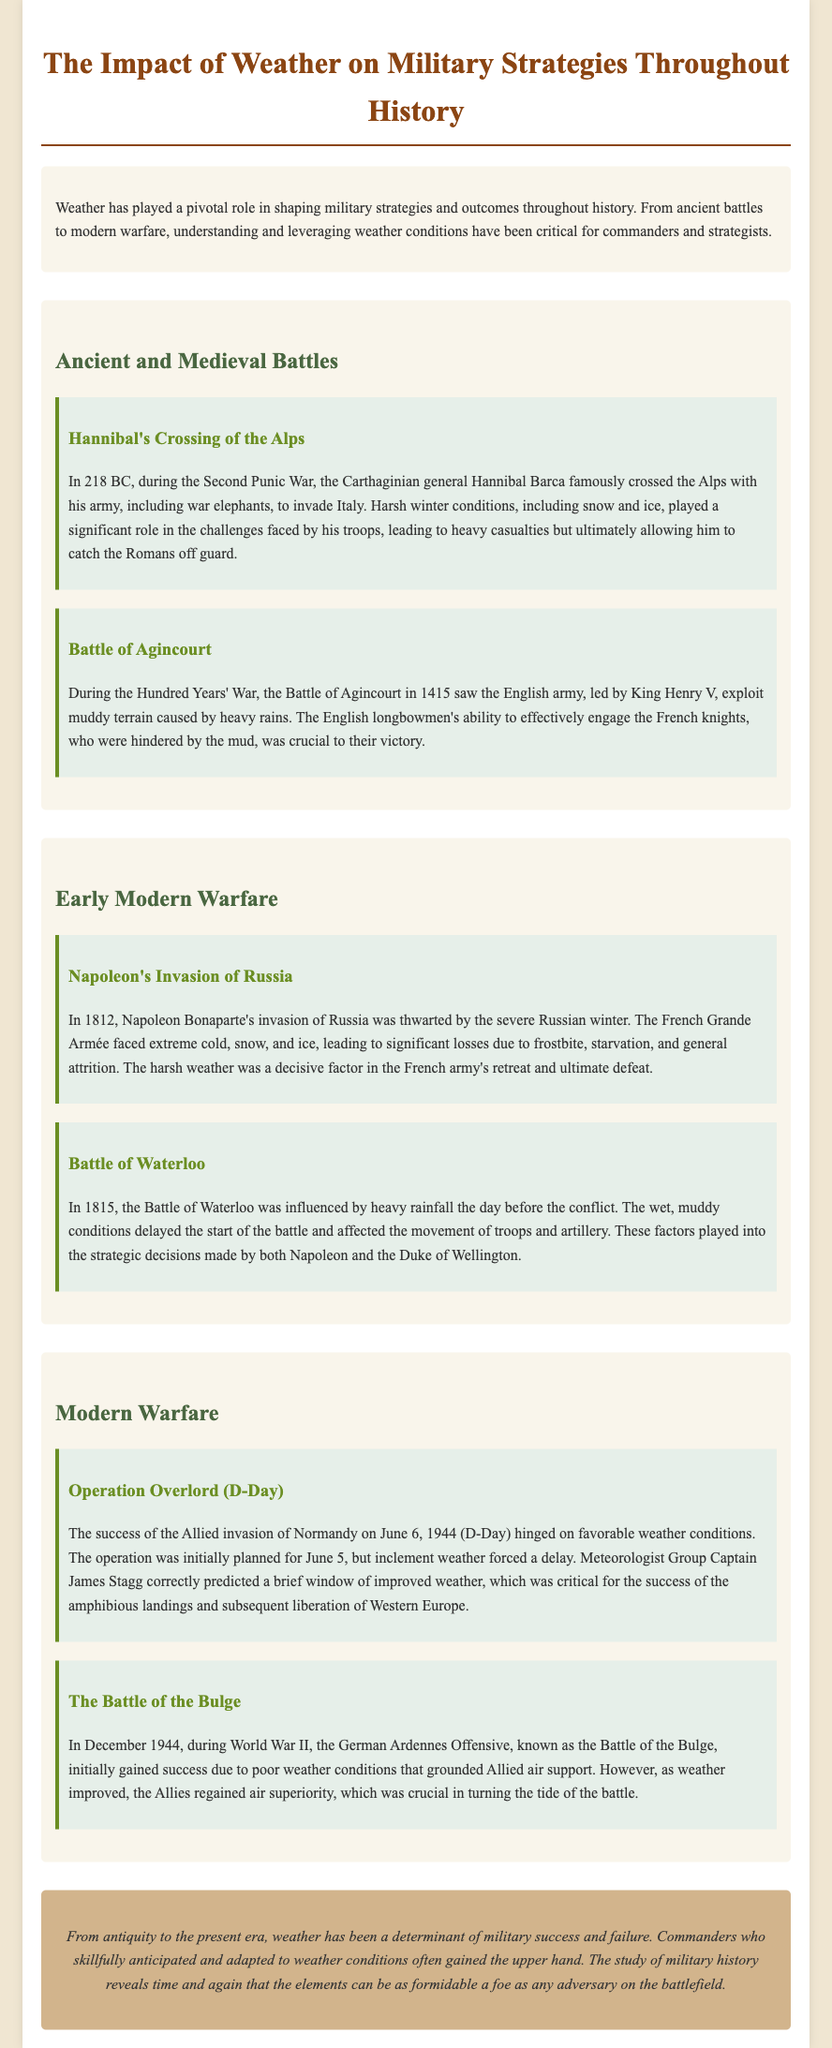What year did Hannibal cross the Alps? Hannibal crossed the Alps in 218 BC during the Second Punic War.
Answer: 218 BC What battle used muddy terrain to their advantage in 1415? The Battle of Agincourt in 1415, where the English army exploited muddy terrain caused by rain.
Answer: Battle of Agincourt What was a significant factor in Napoleon's defeat during his invasion of Russia? The extreme cold, snow, and ice during the Russian winter led to significant losses for Napoleon'sGrande Armée.
Answer: Russian winter Which battle was influenced by heavy rainfall the day before? The Battle of Waterloo in 1815 was significantly affected by heavy rainfall, delaying the battle's start.
Answer: Battle of Waterloo Who correctly predicted the weather for D-Day? Meteorologist Group Captain James Stagg accurately forecasted a brief window of improved weather for D-Day.
Answer: James Stagg How did weather affect the German Ardennes Offensive in 1944? Poor weather initially grounded Allied air support, aiding the German advance in the Battle of the Bulge.
Answer: Grounded Allied air support What is the conclusion of the document regarding the impact of weather on military strategies? The conclusion emphasizes that weather has consistently determined military success and failure throughout history.
Answer: Weather determines success and failure What event was planned for June 5 but delayed due to weather? The Allied invasion of Normandy, known as D-Day, was initially planned for June 5 but was delayed.
Answer: D-Day 